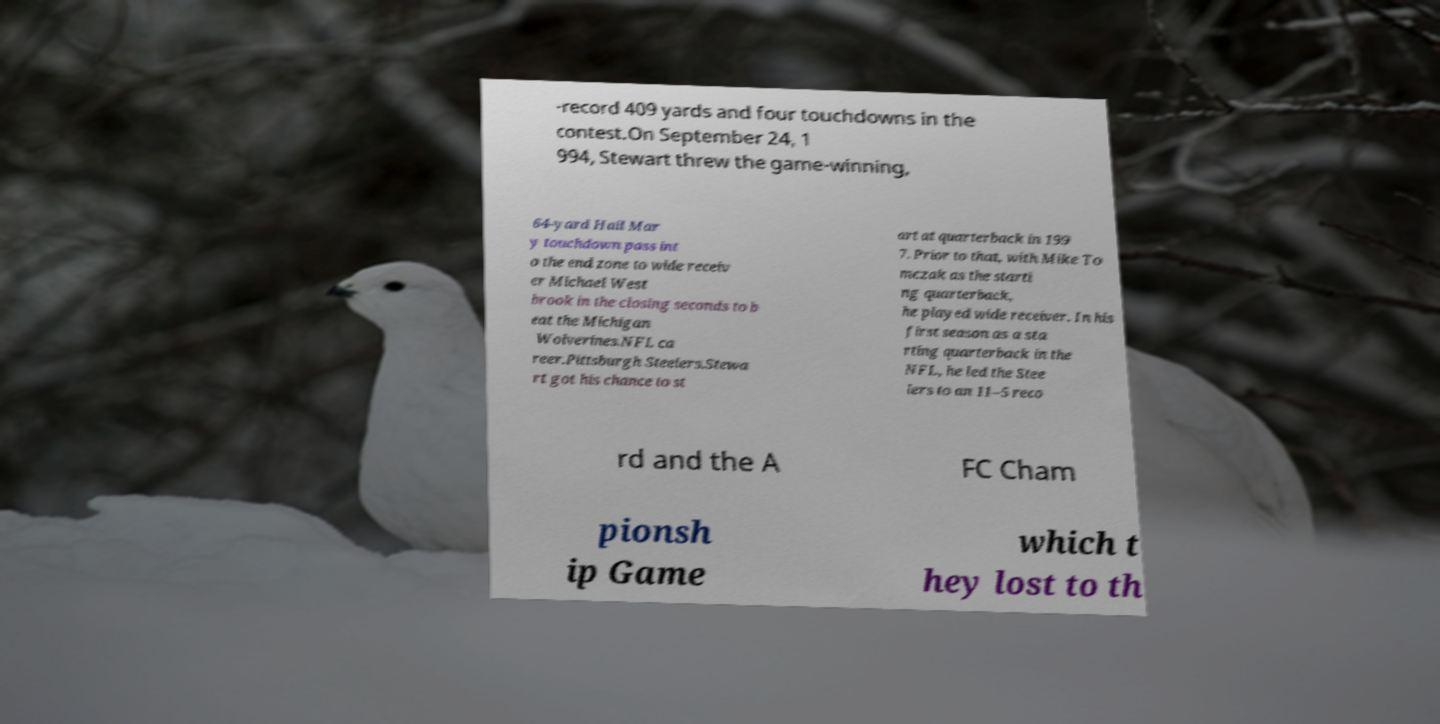Please identify and transcribe the text found in this image. -record 409 yards and four touchdowns in the contest.On September 24, 1 994, Stewart threw the game-winning, 64-yard Hail Mar y touchdown pass int o the end zone to wide receiv er Michael West brook in the closing seconds to b eat the Michigan Wolverines.NFL ca reer.Pittsburgh Steelers.Stewa rt got his chance to st art at quarterback in 199 7. Prior to that, with Mike To mczak as the starti ng quarterback, he played wide receiver. In his first season as a sta rting quarterback in the NFL, he led the Stee lers to an 11–5 reco rd and the A FC Cham pionsh ip Game which t hey lost to th 